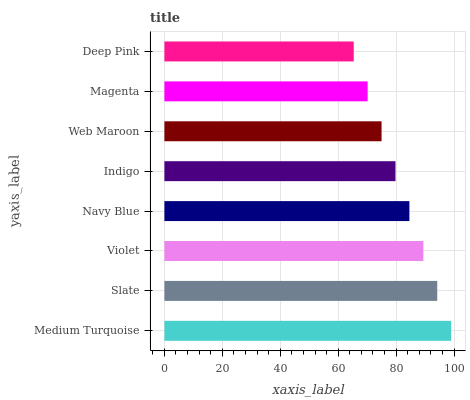Is Deep Pink the minimum?
Answer yes or no. Yes. Is Medium Turquoise the maximum?
Answer yes or no. Yes. Is Slate the minimum?
Answer yes or no. No. Is Slate the maximum?
Answer yes or no. No. Is Medium Turquoise greater than Slate?
Answer yes or no. Yes. Is Slate less than Medium Turquoise?
Answer yes or no. Yes. Is Slate greater than Medium Turquoise?
Answer yes or no. No. Is Medium Turquoise less than Slate?
Answer yes or no. No. Is Navy Blue the high median?
Answer yes or no. Yes. Is Indigo the low median?
Answer yes or no. Yes. Is Web Maroon the high median?
Answer yes or no. No. Is Navy Blue the low median?
Answer yes or no. No. 